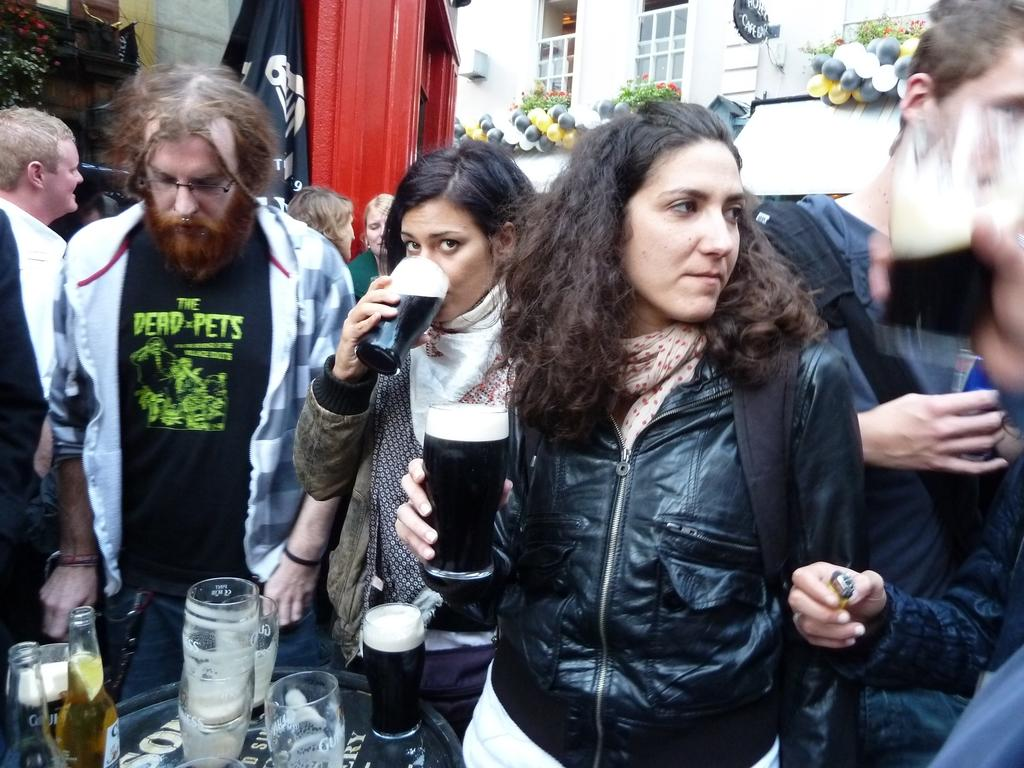What can be seen in the image that represents a symbol or country? There is a flag in the image. What type of building is visible in the image? There is a white color building in the image. What feature does the building have? The building has windows. Who or what is present in the image? There are people standing in the image. What piece of furniture can be seen in the image? There is a table in the image. What items are on the table? There is a bottle and a glass on the table. How many mint leaves are on the table in the image? There are no mint leaves present in the image. What type of lock is securing the building in the image? There is no lock visible in the image; it is a white color building with windows. How many horses are standing near the people in the image? There are no horses present in the image. 